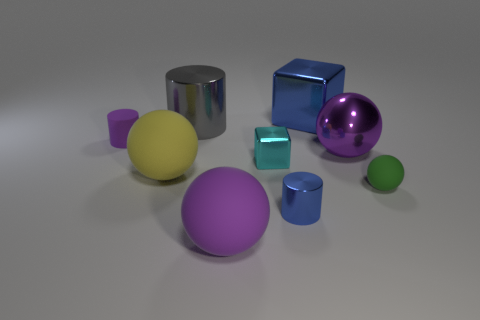Are the big gray cylinder and the tiny green sphere made of the same material?
Ensure brevity in your answer.  No. Are there fewer purple things that are on the right side of the small green ball than big yellow balls on the right side of the large blue thing?
Give a very brief answer. No. The metallic object that is the same color as the large shiny cube is what size?
Your answer should be very brief. Small. There is a big yellow thing behind the purple matte object to the right of the small purple thing; what number of large blue objects are on the left side of it?
Ensure brevity in your answer.  0. Do the big metal cylinder and the metal ball have the same color?
Provide a short and direct response. No. Is there a metallic object that has the same color as the tiny rubber sphere?
Provide a short and direct response. No. There is a rubber object that is the same size as the green ball; what is its color?
Ensure brevity in your answer.  Purple. Are there any purple rubber objects of the same shape as the large yellow thing?
Your answer should be compact. Yes. There is a large rubber object that is the same color as the tiny matte cylinder; what is its shape?
Your answer should be very brief. Sphere. There is a metal cylinder that is behind the blue shiny object that is in front of the big blue metal cube; is there a cyan thing that is behind it?
Provide a short and direct response. No. 